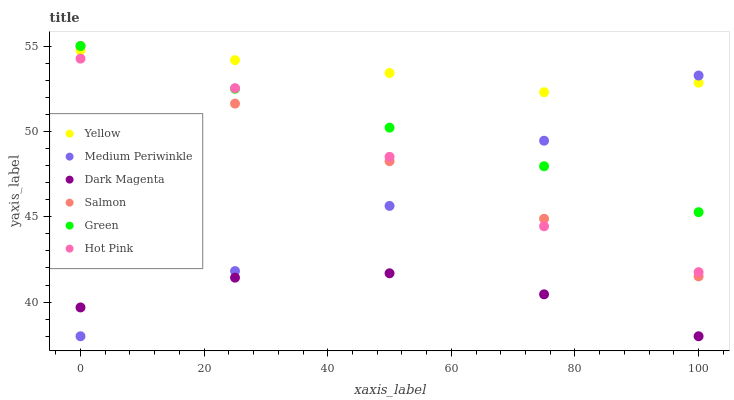Does Dark Magenta have the minimum area under the curve?
Answer yes or no. Yes. Does Yellow have the maximum area under the curve?
Answer yes or no. Yes. Does Medium Periwinkle have the minimum area under the curve?
Answer yes or no. No. Does Medium Periwinkle have the maximum area under the curve?
Answer yes or no. No. Is Salmon the smoothest?
Answer yes or no. Yes. Is Dark Magenta the roughest?
Answer yes or no. Yes. Is Medium Periwinkle the smoothest?
Answer yes or no. No. Is Medium Periwinkle the roughest?
Answer yes or no. No. Does Dark Magenta have the lowest value?
Answer yes or no. Yes. Does Hot Pink have the lowest value?
Answer yes or no. No. Does Green have the highest value?
Answer yes or no. Yes. Does Medium Periwinkle have the highest value?
Answer yes or no. No. Is Hot Pink less than Yellow?
Answer yes or no. Yes. Is Green greater than Dark Magenta?
Answer yes or no. Yes. Does Medium Periwinkle intersect Hot Pink?
Answer yes or no. Yes. Is Medium Periwinkle less than Hot Pink?
Answer yes or no. No. Is Medium Periwinkle greater than Hot Pink?
Answer yes or no. No. Does Hot Pink intersect Yellow?
Answer yes or no. No. 